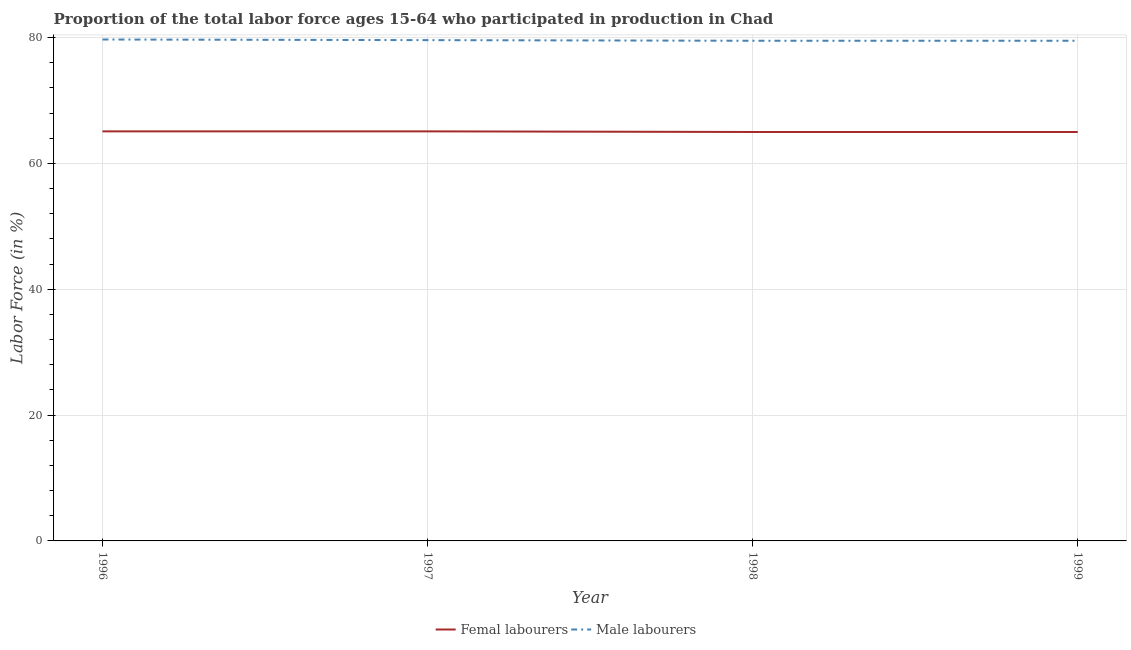How many different coloured lines are there?
Ensure brevity in your answer.  2. What is the percentage of female labor force in 1997?
Offer a very short reply. 65.1. Across all years, what is the maximum percentage of male labour force?
Ensure brevity in your answer.  79.7. Across all years, what is the minimum percentage of male labour force?
Your response must be concise. 79.5. What is the total percentage of male labour force in the graph?
Offer a very short reply. 318.3. What is the difference between the percentage of female labor force in 1996 and that in 1998?
Provide a short and direct response. 0.1. What is the difference between the percentage of female labor force in 1999 and the percentage of male labour force in 1996?
Your response must be concise. -14.7. What is the average percentage of female labor force per year?
Your response must be concise. 65.05. In the year 1998, what is the difference between the percentage of female labor force and percentage of male labour force?
Offer a very short reply. -14.5. What is the ratio of the percentage of female labor force in 1996 to that in 1997?
Ensure brevity in your answer.  1. Is the difference between the percentage of male labour force in 1997 and 1999 greater than the difference between the percentage of female labor force in 1997 and 1999?
Make the answer very short. No. What is the difference between the highest and the second highest percentage of female labor force?
Provide a short and direct response. 0. What is the difference between the highest and the lowest percentage of female labor force?
Your answer should be very brief. 0.1. Is the percentage of male labour force strictly greater than the percentage of female labor force over the years?
Make the answer very short. Yes. Is the percentage of female labor force strictly less than the percentage of male labour force over the years?
Make the answer very short. Yes. How many years are there in the graph?
Offer a very short reply. 4. What is the difference between two consecutive major ticks on the Y-axis?
Your answer should be compact. 20. Are the values on the major ticks of Y-axis written in scientific E-notation?
Provide a short and direct response. No. Does the graph contain any zero values?
Keep it short and to the point. No. Does the graph contain grids?
Offer a terse response. Yes. What is the title of the graph?
Offer a very short reply. Proportion of the total labor force ages 15-64 who participated in production in Chad. Does "Excluding technical cooperation" appear as one of the legend labels in the graph?
Your answer should be very brief. No. What is the label or title of the X-axis?
Keep it short and to the point. Year. What is the label or title of the Y-axis?
Your answer should be very brief. Labor Force (in %). What is the Labor Force (in %) in Femal labourers in 1996?
Keep it short and to the point. 65.1. What is the Labor Force (in %) in Male labourers in 1996?
Your answer should be compact. 79.7. What is the Labor Force (in %) in Femal labourers in 1997?
Your response must be concise. 65.1. What is the Labor Force (in %) of Male labourers in 1997?
Ensure brevity in your answer.  79.6. What is the Labor Force (in %) of Male labourers in 1998?
Provide a short and direct response. 79.5. What is the Labor Force (in %) of Male labourers in 1999?
Provide a succinct answer. 79.5. Across all years, what is the maximum Labor Force (in %) of Femal labourers?
Give a very brief answer. 65.1. Across all years, what is the maximum Labor Force (in %) in Male labourers?
Offer a terse response. 79.7. Across all years, what is the minimum Labor Force (in %) in Femal labourers?
Ensure brevity in your answer.  65. Across all years, what is the minimum Labor Force (in %) in Male labourers?
Provide a succinct answer. 79.5. What is the total Labor Force (in %) in Femal labourers in the graph?
Provide a short and direct response. 260.2. What is the total Labor Force (in %) in Male labourers in the graph?
Offer a very short reply. 318.3. What is the difference between the Labor Force (in %) in Femal labourers in 1996 and that in 1997?
Make the answer very short. 0. What is the difference between the Labor Force (in %) of Femal labourers in 1996 and that in 1998?
Your answer should be very brief. 0.1. What is the difference between the Labor Force (in %) of Femal labourers in 1997 and that in 1998?
Your answer should be compact. 0.1. What is the difference between the Labor Force (in %) in Femal labourers in 1998 and that in 1999?
Your answer should be compact. 0. What is the difference between the Labor Force (in %) of Male labourers in 1998 and that in 1999?
Give a very brief answer. 0. What is the difference between the Labor Force (in %) in Femal labourers in 1996 and the Labor Force (in %) in Male labourers in 1998?
Provide a succinct answer. -14.4. What is the difference between the Labor Force (in %) of Femal labourers in 1996 and the Labor Force (in %) of Male labourers in 1999?
Your answer should be very brief. -14.4. What is the difference between the Labor Force (in %) in Femal labourers in 1997 and the Labor Force (in %) in Male labourers in 1998?
Keep it short and to the point. -14.4. What is the difference between the Labor Force (in %) in Femal labourers in 1997 and the Labor Force (in %) in Male labourers in 1999?
Offer a terse response. -14.4. What is the difference between the Labor Force (in %) in Femal labourers in 1998 and the Labor Force (in %) in Male labourers in 1999?
Give a very brief answer. -14.5. What is the average Labor Force (in %) in Femal labourers per year?
Provide a short and direct response. 65.05. What is the average Labor Force (in %) of Male labourers per year?
Give a very brief answer. 79.58. In the year 1996, what is the difference between the Labor Force (in %) in Femal labourers and Labor Force (in %) in Male labourers?
Offer a terse response. -14.6. In the year 1997, what is the difference between the Labor Force (in %) of Femal labourers and Labor Force (in %) of Male labourers?
Provide a short and direct response. -14.5. In the year 1999, what is the difference between the Labor Force (in %) of Femal labourers and Labor Force (in %) of Male labourers?
Give a very brief answer. -14.5. What is the ratio of the Labor Force (in %) of Femal labourers in 1996 to that in 1997?
Make the answer very short. 1. What is the ratio of the Labor Force (in %) in Male labourers in 1996 to that in 1997?
Provide a short and direct response. 1. What is the ratio of the Labor Force (in %) of Male labourers in 1996 to that in 1998?
Provide a succinct answer. 1. What is the ratio of the Labor Force (in %) in Femal labourers in 1997 to that in 1998?
Give a very brief answer. 1. What is the ratio of the Labor Force (in %) in Male labourers in 1997 to that in 1999?
Provide a succinct answer. 1. What is the ratio of the Labor Force (in %) of Femal labourers in 1998 to that in 1999?
Give a very brief answer. 1. 